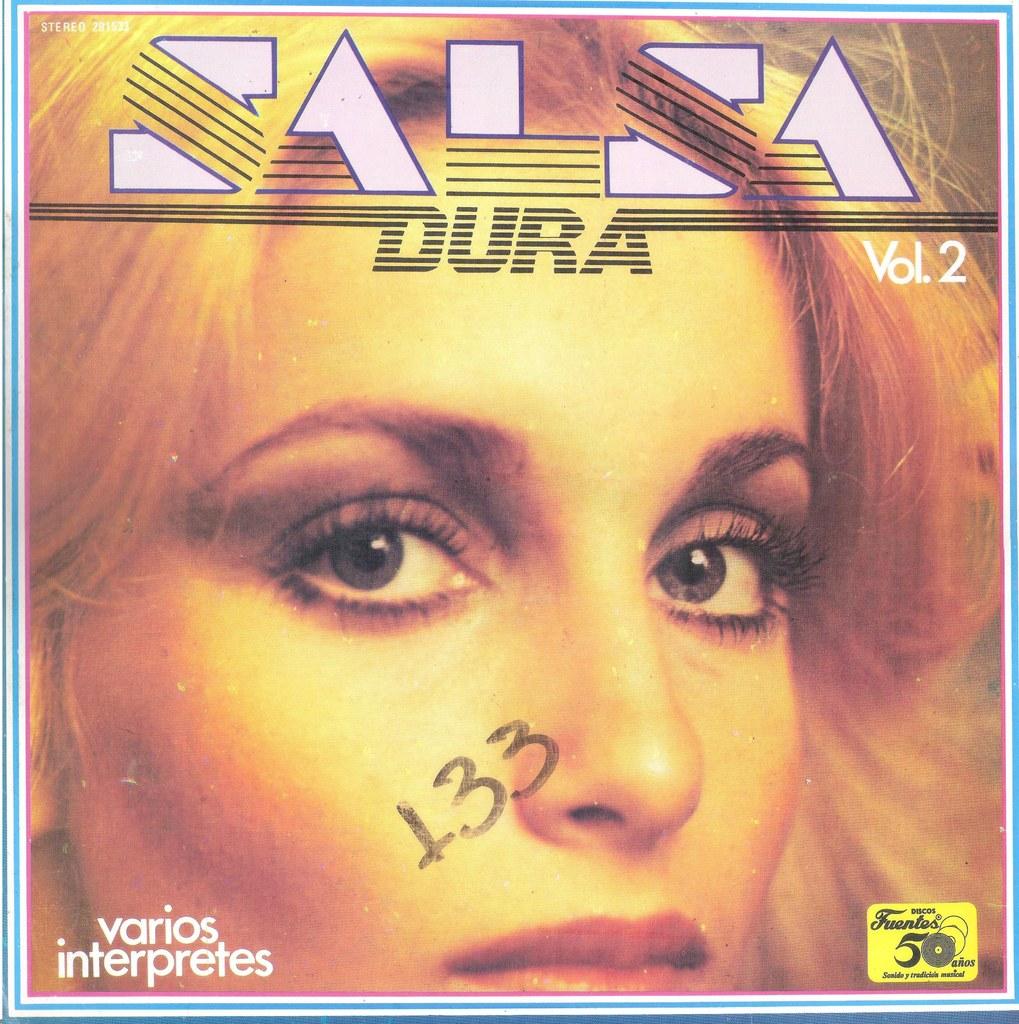Who is the singer?
Offer a very short reply. Dura. 